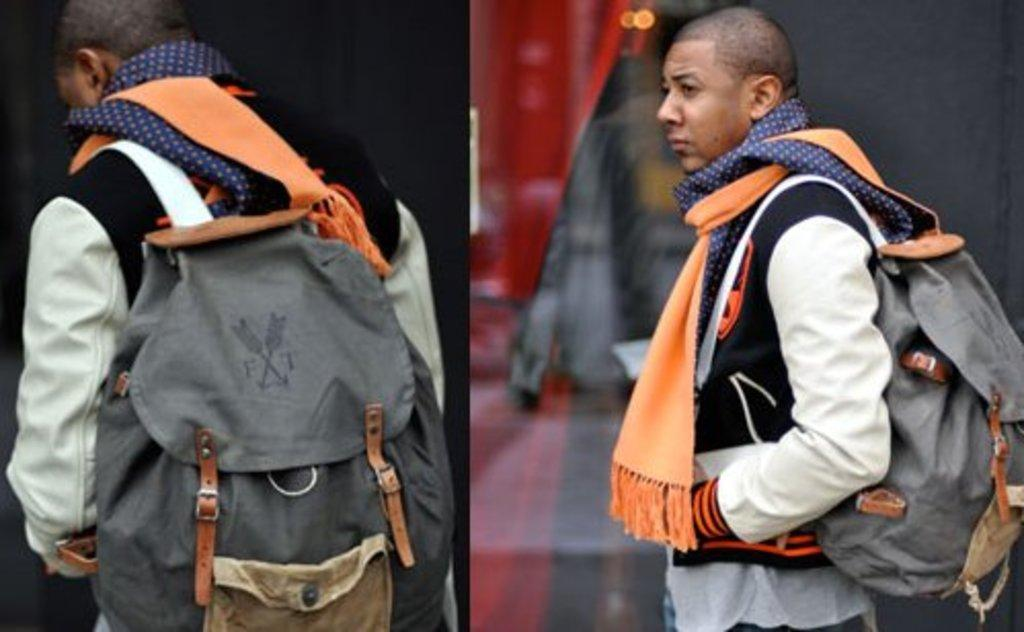<image>
Summarize the visual content of the image. the man is wearing a backpack with two arrows and F and T 